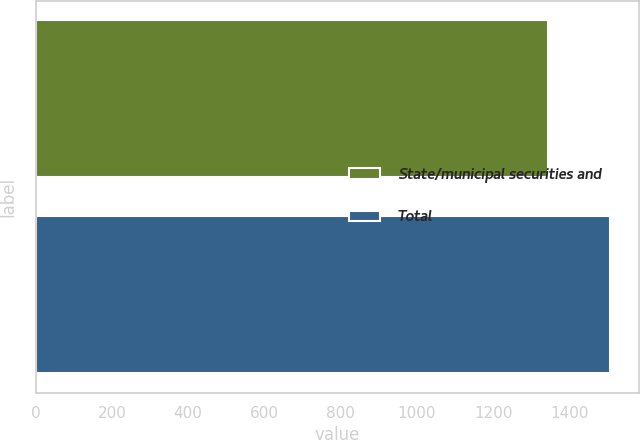Convert chart. <chart><loc_0><loc_0><loc_500><loc_500><bar_chart><fcel>State/municipal securities and<fcel>Total<nl><fcel>1344<fcel>1507<nl></chart> 